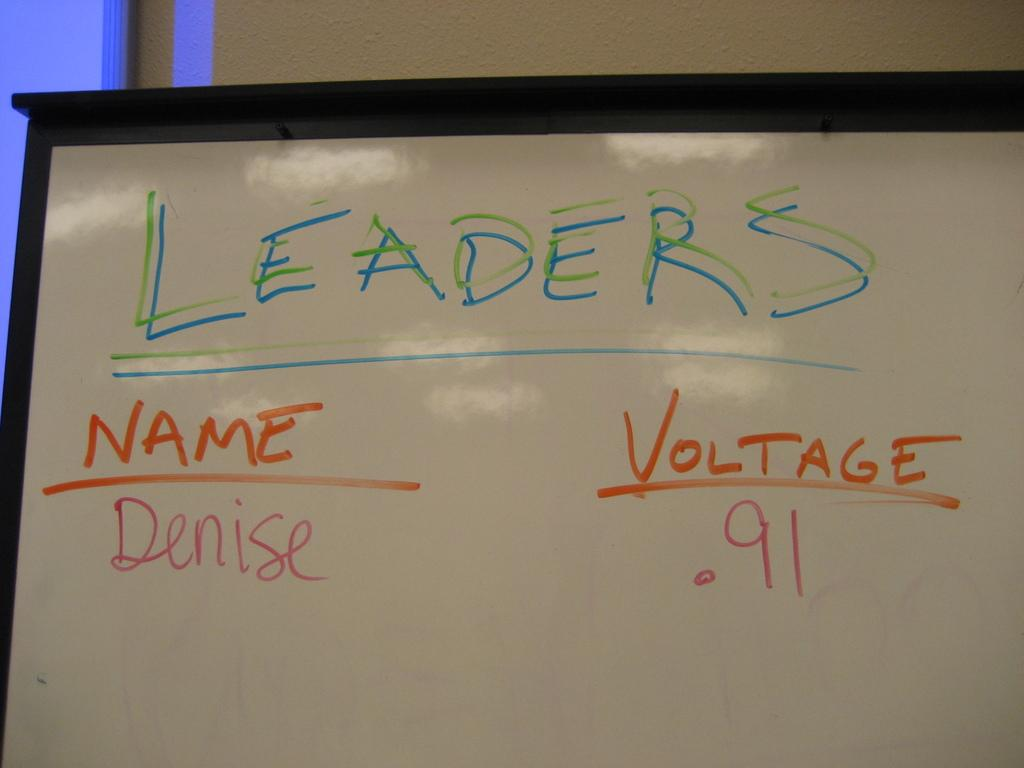<image>
Give a short and clear explanation of the subsequent image. A white board has a list of Leaders written on it and their stats. 